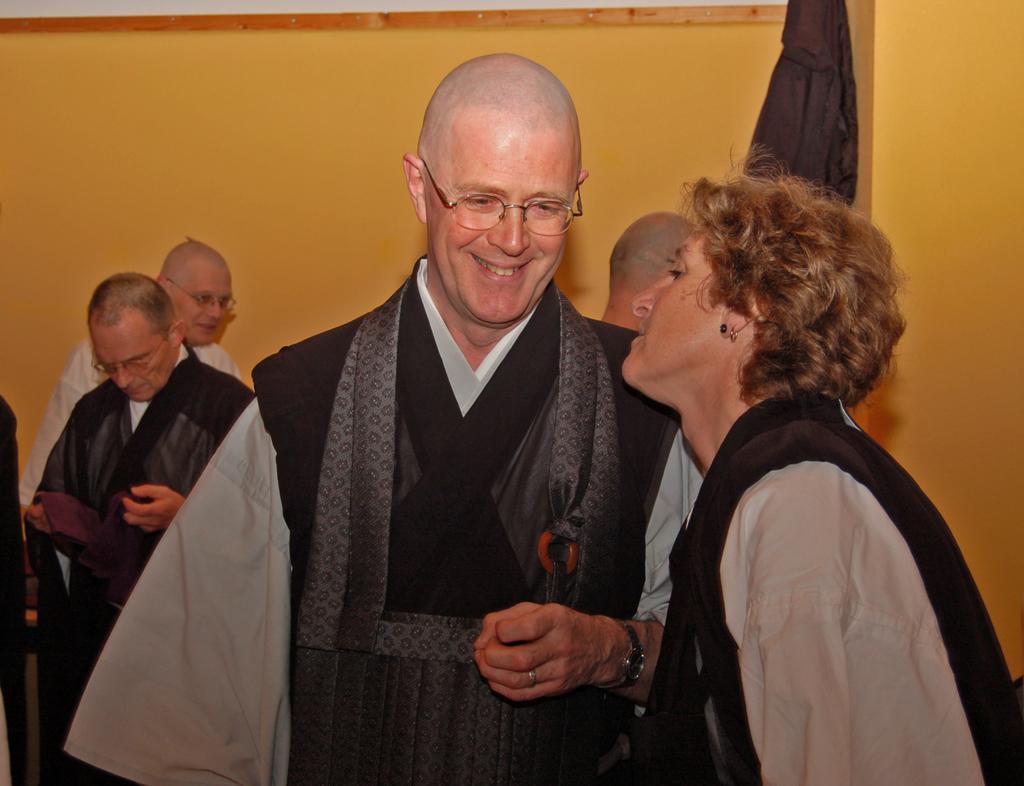In one or two sentences, can you explain what this image depicts? In this image we can see many people. Few are wearing specs. In the back there is a wall. One person is wearing watch and ring. In the background there is a wall. 